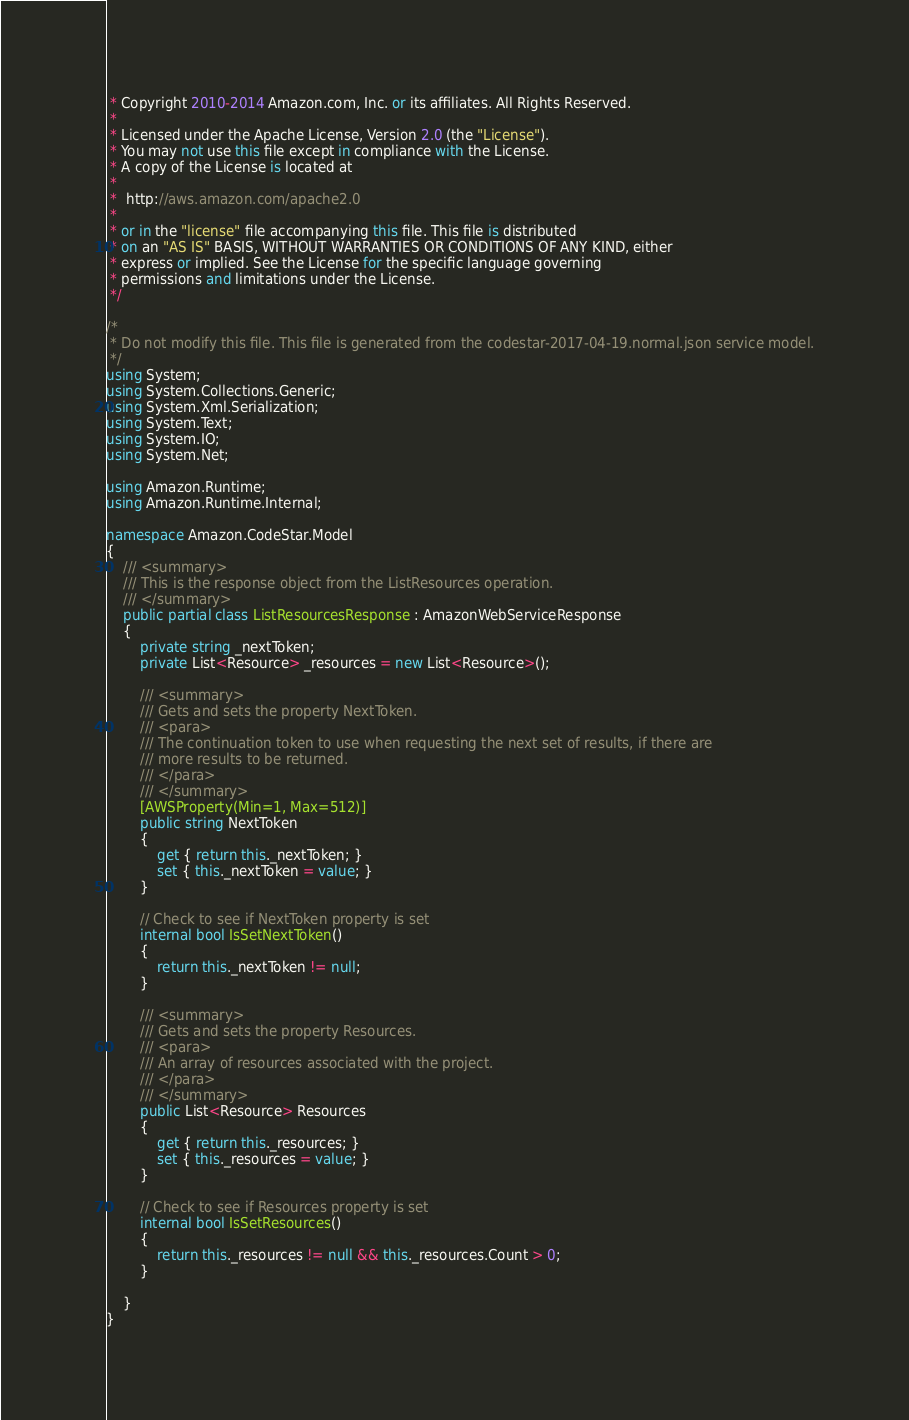Convert code to text. <code><loc_0><loc_0><loc_500><loc_500><_C#_> * Copyright 2010-2014 Amazon.com, Inc. or its affiliates. All Rights Reserved.
 * 
 * Licensed under the Apache License, Version 2.0 (the "License").
 * You may not use this file except in compliance with the License.
 * A copy of the License is located at
 * 
 *  http://aws.amazon.com/apache2.0
 * 
 * or in the "license" file accompanying this file. This file is distributed
 * on an "AS IS" BASIS, WITHOUT WARRANTIES OR CONDITIONS OF ANY KIND, either
 * express or implied. See the License for the specific language governing
 * permissions and limitations under the License.
 */

/*
 * Do not modify this file. This file is generated from the codestar-2017-04-19.normal.json service model.
 */
using System;
using System.Collections.Generic;
using System.Xml.Serialization;
using System.Text;
using System.IO;
using System.Net;

using Amazon.Runtime;
using Amazon.Runtime.Internal;

namespace Amazon.CodeStar.Model
{
    /// <summary>
    /// This is the response object from the ListResources operation.
    /// </summary>
    public partial class ListResourcesResponse : AmazonWebServiceResponse
    {
        private string _nextToken;
        private List<Resource> _resources = new List<Resource>();

        /// <summary>
        /// Gets and sets the property NextToken. 
        /// <para>
        /// The continuation token to use when requesting the next set of results, if there are
        /// more results to be returned.
        /// </para>
        /// </summary>
        [AWSProperty(Min=1, Max=512)]
        public string NextToken
        {
            get { return this._nextToken; }
            set { this._nextToken = value; }
        }

        // Check to see if NextToken property is set
        internal bool IsSetNextToken()
        {
            return this._nextToken != null;
        }

        /// <summary>
        /// Gets and sets the property Resources. 
        /// <para>
        /// An array of resources associated with the project. 
        /// </para>
        /// </summary>
        public List<Resource> Resources
        {
            get { return this._resources; }
            set { this._resources = value; }
        }

        // Check to see if Resources property is set
        internal bool IsSetResources()
        {
            return this._resources != null && this._resources.Count > 0; 
        }

    }
}</code> 